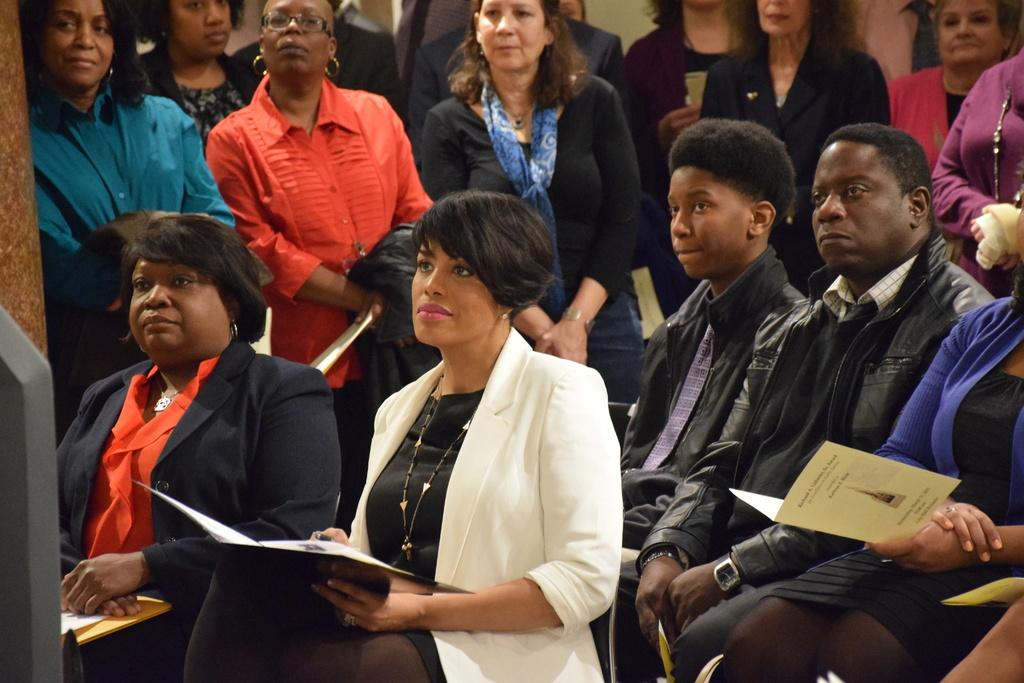What are the people in the image doing? There is a group of people sitting on chairs in the image. What are some of the people holding? Two of the people are holding cards. Can you describe the people in the background of the image? There is a group of people standing in the background of the image. What type of car is parked in front of the group of people in the image? There is no car present in the image; it only features a group of people sitting on chairs and standing in the background. 